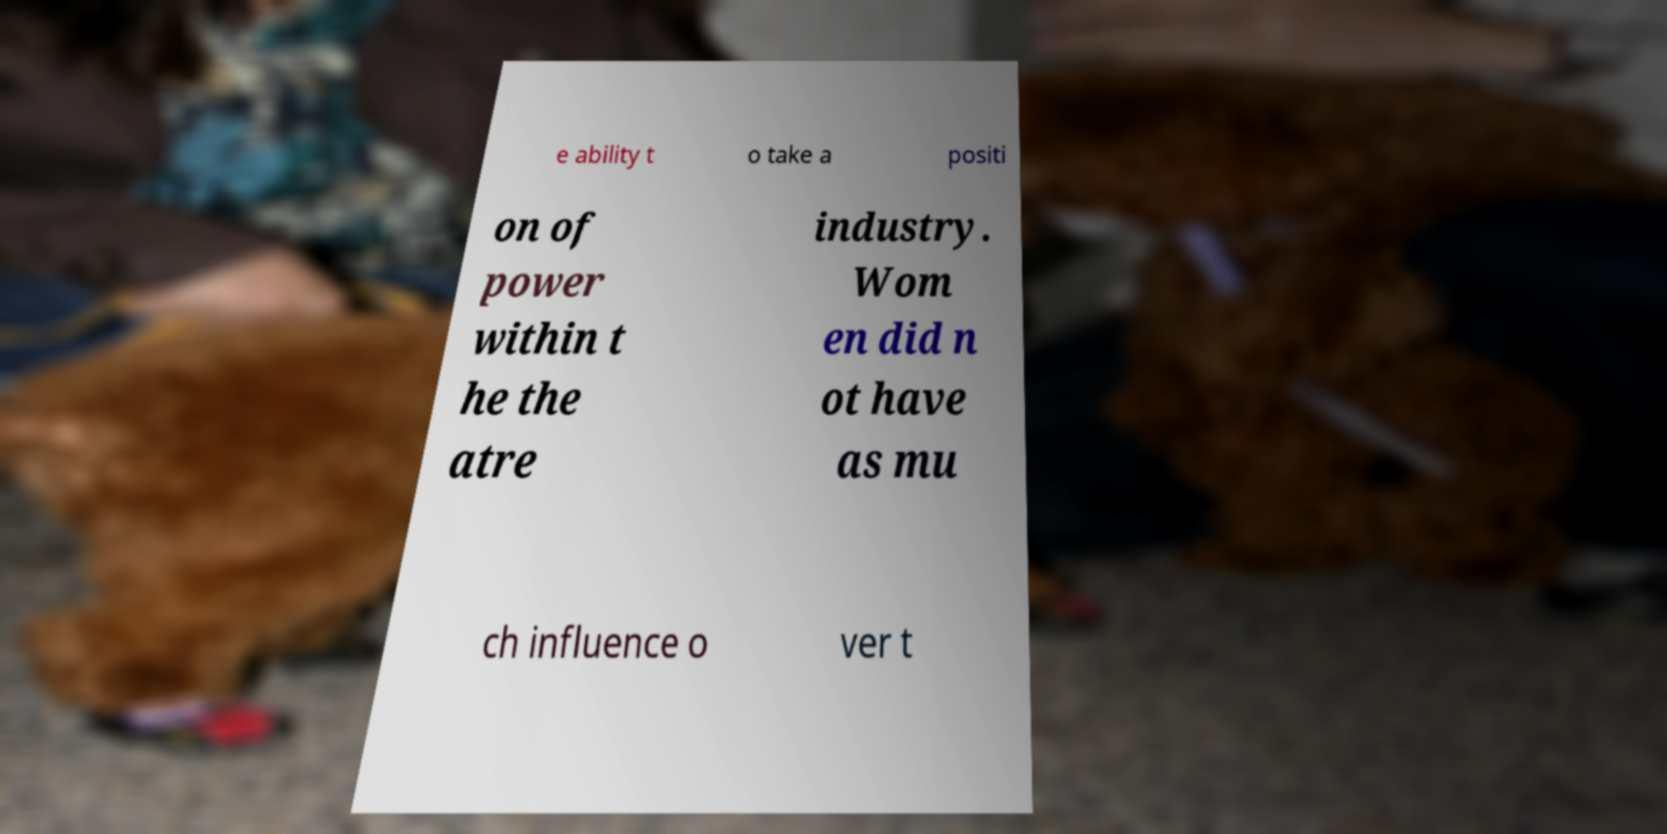Can you read and provide the text displayed in the image?This photo seems to have some interesting text. Can you extract and type it out for me? e ability t o take a positi on of power within t he the atre industry. Wom en did n ot have as mu ch influence o ver t 